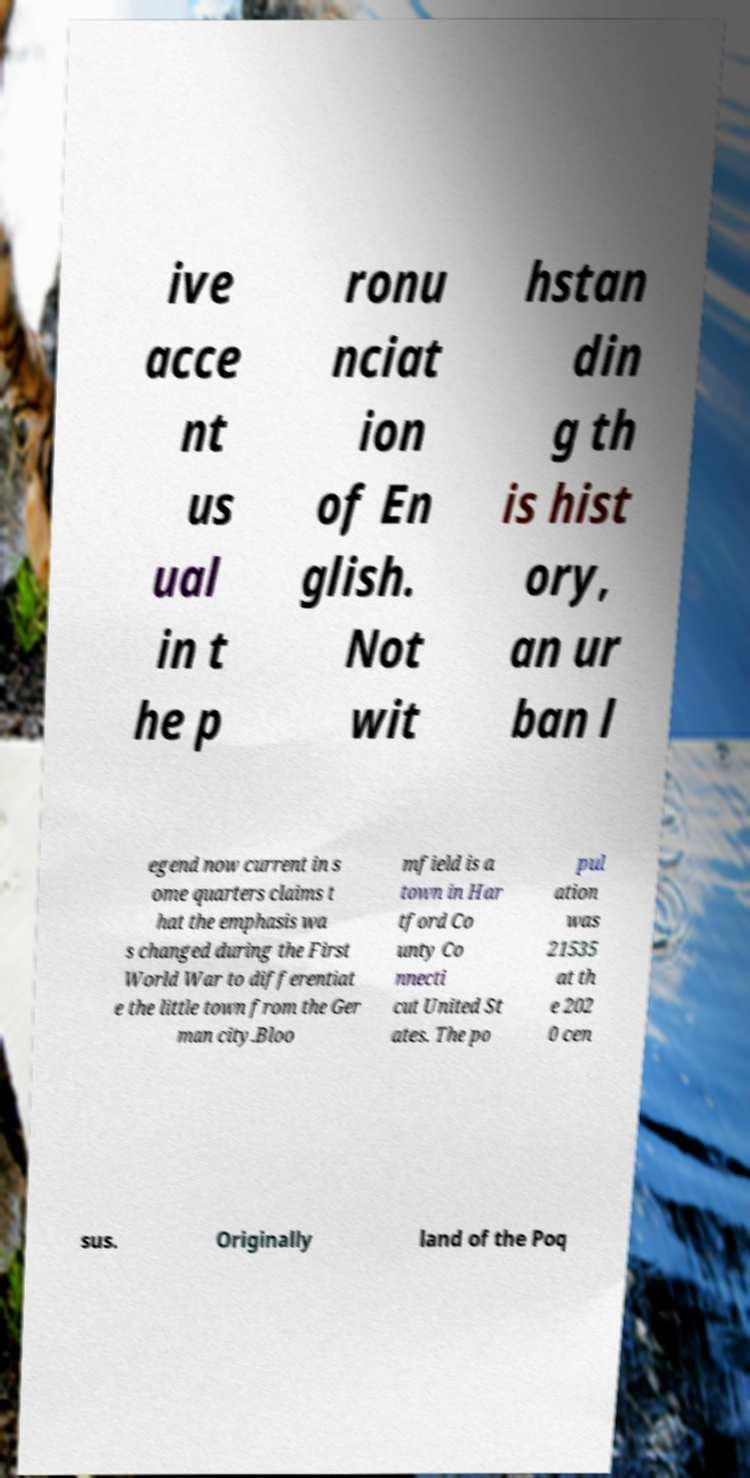Please read and relay the text visible in this image. What does it say? ive acce nt us ual in t he p ronu nciat ion of En glish. Not wit hstan din g th is hist ory, an ur ban l egend now current in s ome quarters claims t hat the emphasis wa s changed during the First World War to differentiat e the little town from the Ger man city.Bloo mfield is a town in Har tford Co unty Co nnecti cut United St ates. The po pul ation was 21535 at th e 202 0 cen sus. Originally land of the Poq 